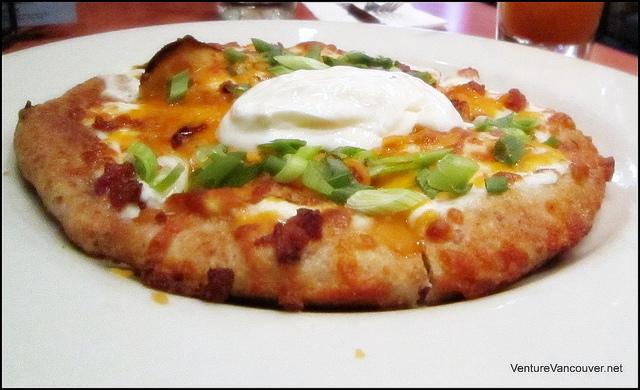What type of food is this?
Give a very brief answer. Pizza. What are the green items on the pizza?
Concise answer only. Onions. Is there sour cream on the food?
Give a very brief answer. Yes. 